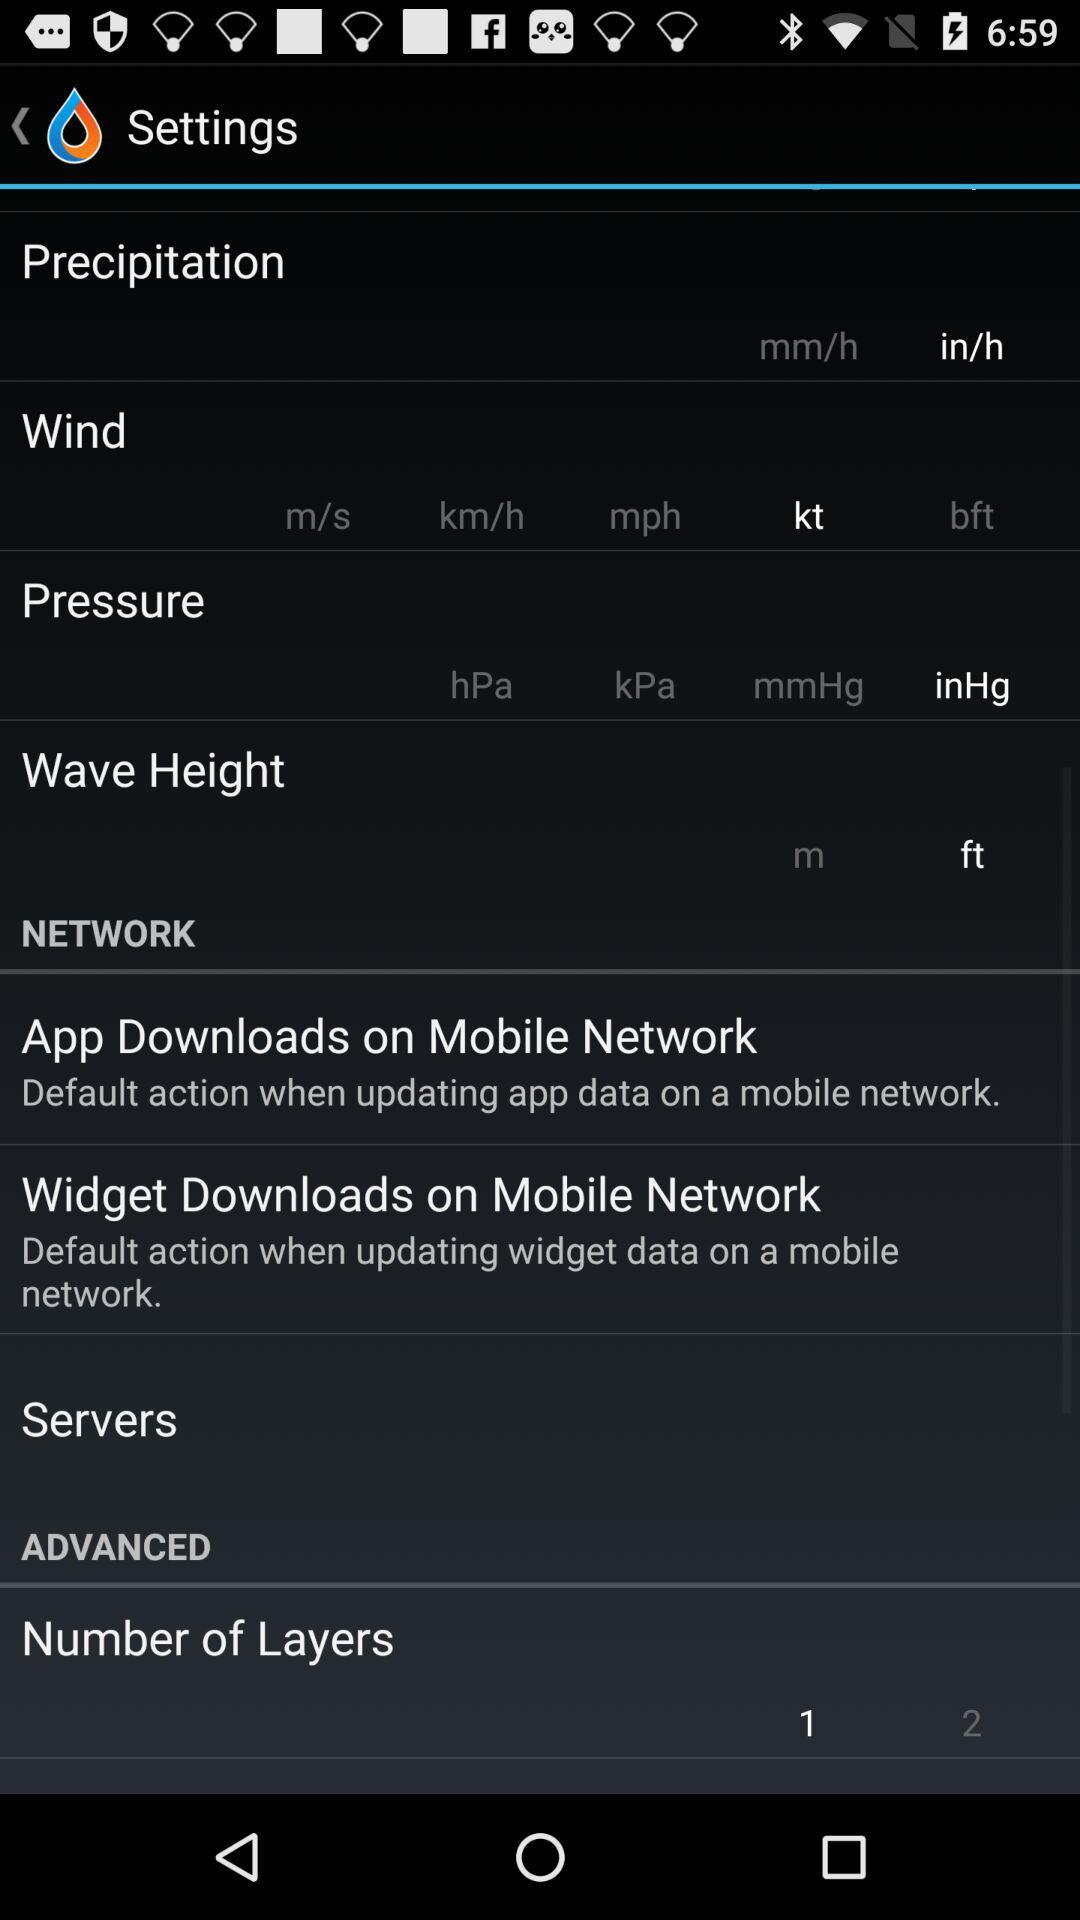How many units are there to choose from for the wave height setting?
Answer the question using a single word or phrase. 2 